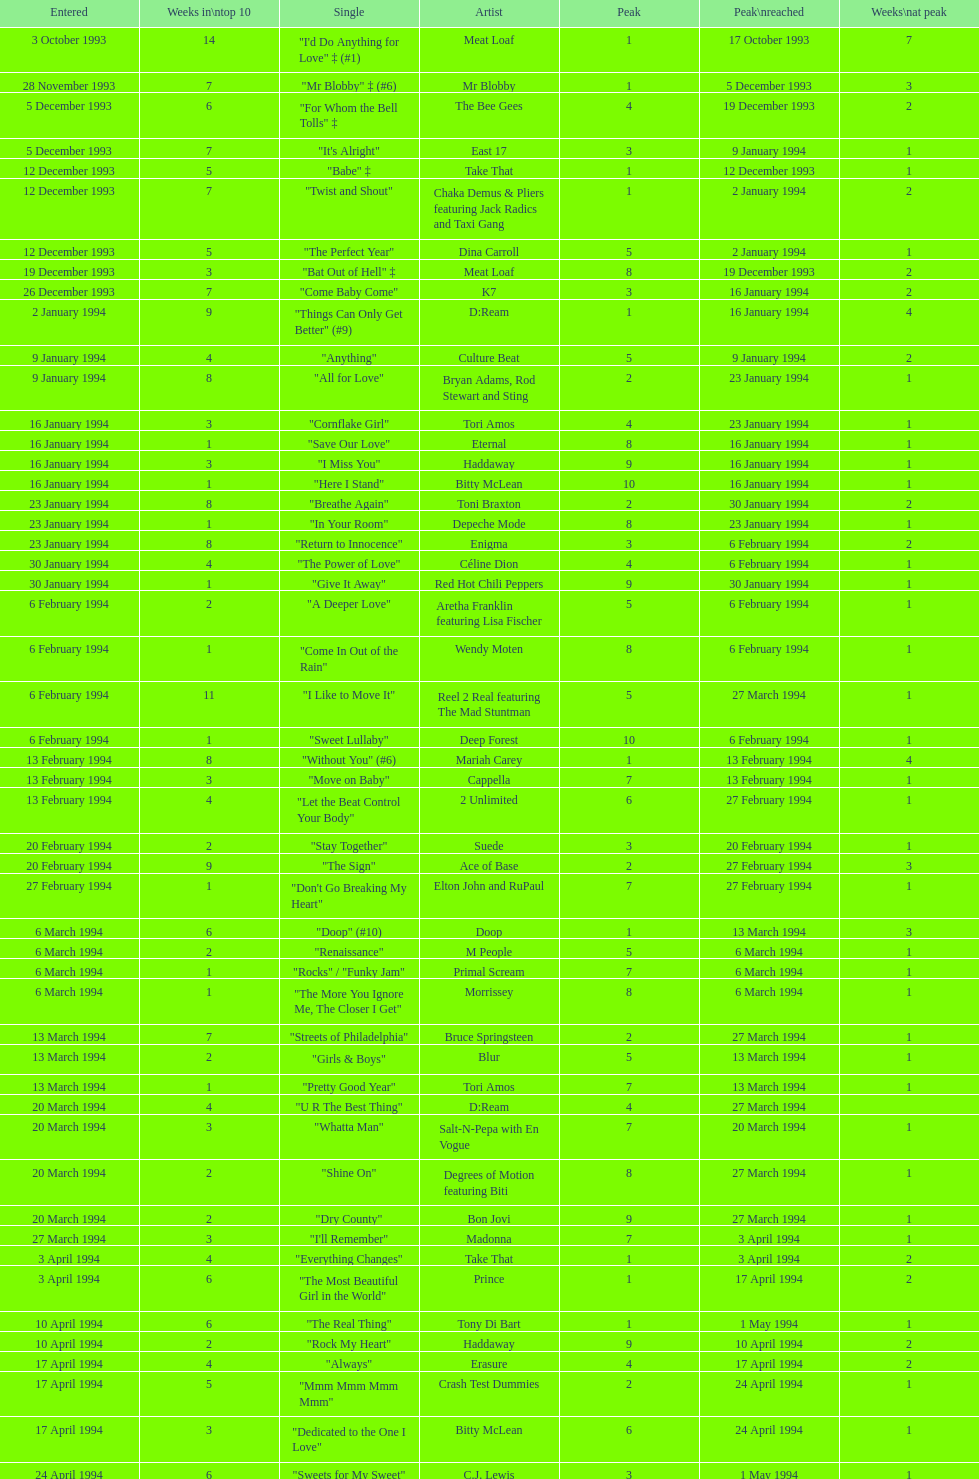This song released by celine dion spent 17 weeks on the uk singles chart in 1994, which one was it? "Think Twice". 